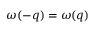Convert formula to latex. <formula><loc_0><loc_0><loc_500><loc_500>\omega ( - q ) = \omega ( q )</formula> 